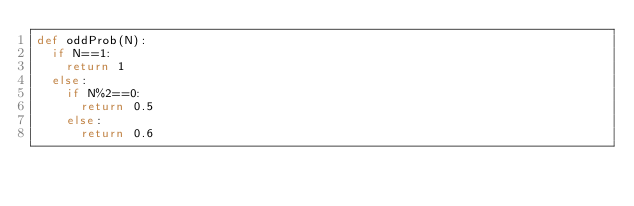<code> <loc_0><loc_0><loc_500><loc_500><_Python_>def oddProb(N):
  if N==1:
    return 1
  else:
    if N%2==0:
      return 0.5
    else:
      return 0.6</code> 